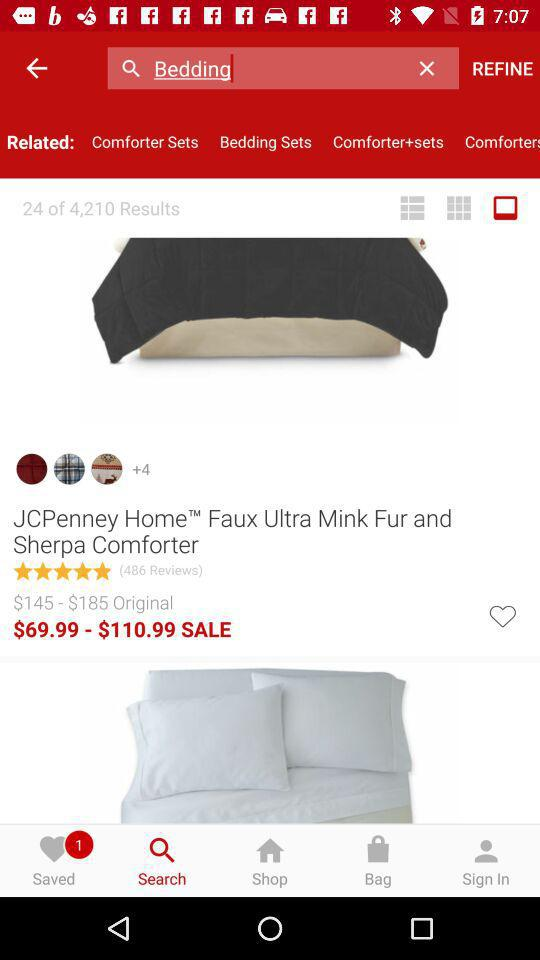How many results in total are there? There are 4,210 results in total. 